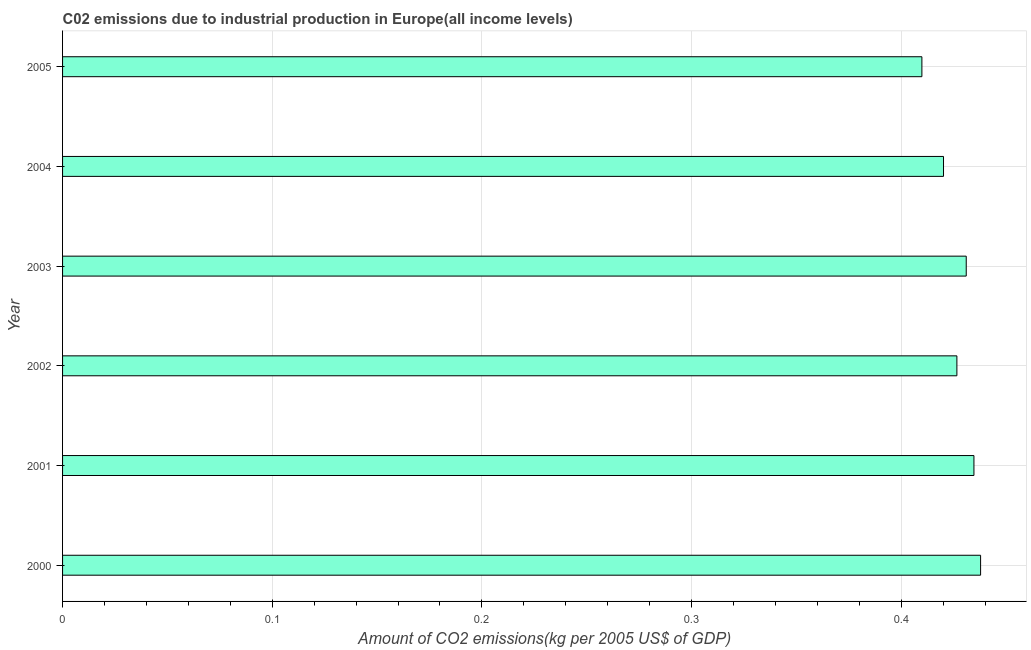What is the title of the graph?
Your answer should be compact. C02 emissions due to industrial production in Europe(all income levels). What is the label or title of the X-axis?
Your answer should be very brief. Amount of CO2 emissions(kg per 2005 US$ of GDP). What is the amount of co2 emissions in 2004?
Offer a very short reply. 0.42. Across all years, what is the maximum amount of co2 emissions?
Your answer should be very brief. 0.44. Across all years, what is the minimum amount of co2 emissions?
Offer a terse response. 0.41. In which year was the amount of co2 emissions maximum?
Offer a terse response. 2000. In which year was the amount of co2 emissions minimum?
Your response must be concise. 2005. What is the sum of the amount of co2 emissions?
Ensure brevity in your answer.  2.56. What is the difference between the amount of co2 emissions in 2000 and 2001?
Provide a short and direct response. 0. What is the average amount of co2 emissions per year?
Make the answer very short. 0.43. What is the median amount of co2 emissions?
Give a very brief answer. 0.43. In how many years, is the amount of co2 emissions greater than 0.32 kg per 2005 US$ of GDP?
Offer a terse response. 6. Do a majority of the years between 2002 and 2000 (inclusive) have amount of co2 emissions greater than 0.1 kg per 2005 US$ of GDP?
Your response must be concise. Yes. What is the ratio of the amount of co2 emissions in 2003 to that in 2004?
Ensure brevity in your answer.  1.03. Is the amount of co2 emissions in 2000 less than that in 2005?
Make the answer very short. No. What is the difference between the highest and the second highest amount of co2 emissions?
Give a very brief answer. 0. Is the sum of the amount of co2 emissions in 2004 and 2005 greater than the maximum amount of co2 emissions across all years?
Give a very brief answer. Yes. What is the difference between the highest and the lowest amount of co2 emissions?
Give a very brief answer. 0.03. In how many years, is the amount of co2 emissions greater than the average amount of co2 emissions taken over all years?
Provide a short and direct response. 3. What is the Amount of CO2 emissions(kg per 2005 US$ of GDP) of 2000?
Provide a short and direct response. 0.44. What is the Amount of CO2 emissions(kg per 2005 US$ of GDP) in 2001?
Provide a succinct answer. 0.43. What is the Amount of CO2 emissions(kg per 2005 US$ of GDP) of 2002?
Your answer should be very brief. 0.43. What is the Amount of CO2 emissions(kg per 2005 US$ of GDP) in 2003?
Give a very brief answer. 0.43. What is the Amount of CO2 emissions(kg per 2005 US$ of GDP) of 2004?
Ensure brevity in your answer.  0.42. What is the Amount of CO2 emissions(kg per 2005 US$ of GDP) of 2005?
Offer a very short reply. 0.41. What is the difference between the Amount of CO2 emissions(kg per 2005 US$ of GDP) in 2000 and 2001?
Your answer should be very brief. 0. What is the difference between the Amount of CO2 emissions(kg per 2005 US$ of GDP) in 2000 and 2002?
Your answer should be very brief. 0.01. What is the difference between the Amount of CO2 emissions(kg per 2005 US$ of GDP) in 2000 and 2003?
Your answer should be compact. 0.01. What is the difference between the Amount of CO2 emissions(kg per 2005 US$ of GDP) in 2000 and 2004?
Give a very brief answer. 0.02. What is the difference between the Amount of CO2 emissions(kg per 2005 US$ of GDP) in 2000 and 2005?
Your response must be concise. 0.03. What is the difference between the Amount of CO2 emissions(kg per 2005 US$ of GDP) in 2001 and 2002?
Your answer should be compact. 0.01. What is the difference between the Amount of CO2 emissions(kg per 2005 US$ of GDP) in 2001 and 2003?
Your response must be concise. 0. What is the difference between the Amount of CO2 emissions(kg per 2005 US$ of GDP) in 2001 and 2004?
Offer a very short reply. 0.01. What is the difference between the Amount of CO2 emissions(kg per 2005 US$ of GDP) in 2001 and 2005?
Give a very brief answer. 0.02. What is the difference between the Amount of CO2 emissions(kg per 2005 US$ of GDP) in 2002 and 2003?
Offer a very short reply. -0. What is the difference between the Amount of CO2 emissions(kg per 2005 US$ of GDP) in 2002 and 2004?
Your answer should be very brief. 0.01. What is the difference between the Amount of CO2 emissions(kg per 2005 US$ of GDP) in 2002 and 2005?
Your answer should be compact. 0.02. What is the difference between the Amount of CO2 emissions(kg per 2005 US$ of GDP) in 2003 and 2004?
Make the answer very short. 0.01. What is the difference between the Amount of CO2 emissions(kg per 2005 US$ of GDP) in 2003 and 2005?
Your answer should be very brief. 0.02. What is the difference between the Amount of CO2 emissions(kg per 2005 US$ of GDP) in 2004 and 2005?
Your answer should be very brief. 0.01. What is the ratio of the Amount of CO2 emissions(kg per 2005 US$ of GDP) in 2000 to that in 2001?
Your answer should be very brief. 1.01. What is the ratio of the Amount of CO2 emissions(kg per 2005 US$ of GDP) in 2000 to that in 2002?
Offer a terse response. 1.03. What is the ratio of the Amount of CO2 emissions(kg per 2005 US$ of GDP) in 2000 to that in 2003?
Keep it short and to the point. 1.02. What is the ratio of the Amount of CO2 emissions(kg per 2005 US$ of GDP) in 2000 to that in 2004?
Your answer should be very brief. 1.04. What is the ratio of the Amount of CO2 emissions(kg per 2005 US$ of GDP) in 2000 to that in 2005?
Give a very brief answer. 1.07. What is the ratio of the Amount of CO2 emissions(kg per 2005 US$ of GDP) in 2001 to that in 2003?
Keep it short and to the point. 1.01. What is the ratio of the Amount of CO2 emissions(kg per 2005 US$ of GDP) in 2001 to that in 2004?
Your answer should be compact. 1.03. What is the ratio of the Amount of CO2 emissions(kg per 2005 US$ of GDP) in 2001 to that in 2005?
Your answer should be very brief. 1.06. What is the ratio of the Amount of CO2 emissions(kg per 2005 US$ of GDP) in 2002 to that in 2004?
Your response must be concise. 1.01. What is the ratio of the Amount of CO2 emissions(kg per 2005 US$ of GDP) in 2002 to that in 2005?
Give a very brief answer. 1.04. What is the ratio of the Amount of CO2 emissions(kg per 2005 US$ of GDP) in 2003 to that in 2005?
Keep it short and to the point. 1.05. What is the ratio of the Amount of CO2 emissions(kg per 2005 US$ of GDP) in 2004 to that in 2005?
Provide a succinct answer. 1.02. 